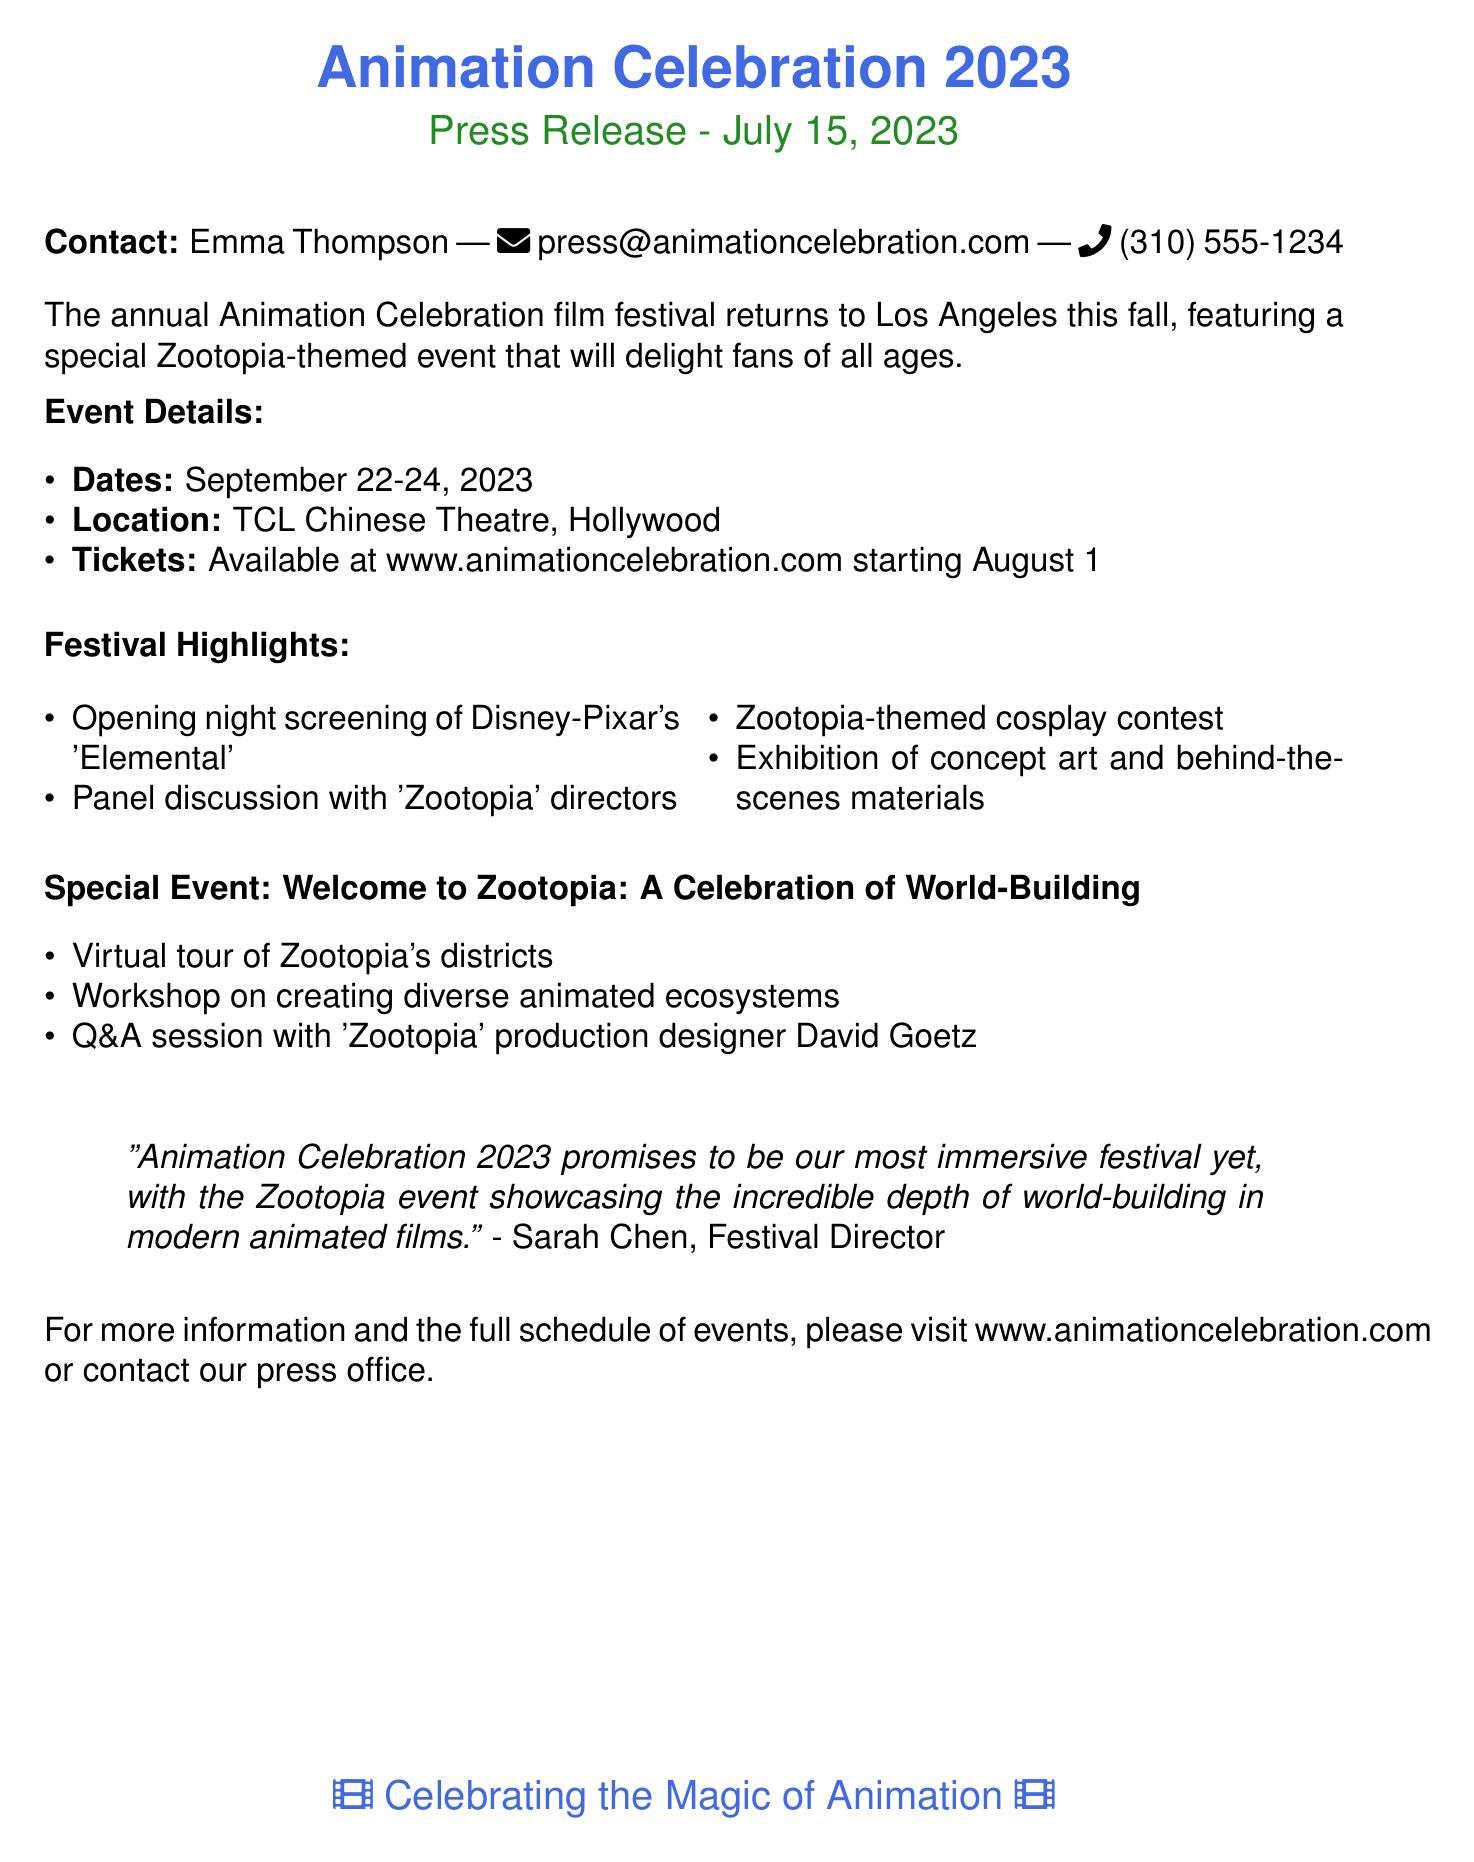What are the festival dates? The festival dates are explicitly mentioned in the document as September 22-24, 2023.
Answer: September 22-24, 2023 Where is the festival located? The location of the festival is stated in the document as TCL Chinese Theatre, Hollywood.
Answer: TCL Chinese Theatre, Hollywood When do ticket sales begin? The document mentions that tickets will be available starting August 1.
Answer: August 1 Who is the production designer featured in the Q&A session? The name of the production designer is mentioned in the special event details as David Goetz.
Answer: David Goetz What is the title of the opening night screening? The title is provided in the festival highlights section, indicating the screening will be of Disney-Pixar's 'Elemental.'
Answer: Disney-Pixar's 'Elemental' What type of contest will be held? The document specifies a Zootopia-themed cosplay contest will take place.
Answer: Cosplay contest What is the special event focused on? The special event is highlighted as "Welcome to Zootopia: A Celebration of World-Building."
Answer: Welcome to Zootopia: A Celebration of World-Building Who is quoted in the press release? The press release includes a quote from Sarah Chen, the Festival Director.
Answer: Sarah Chen 